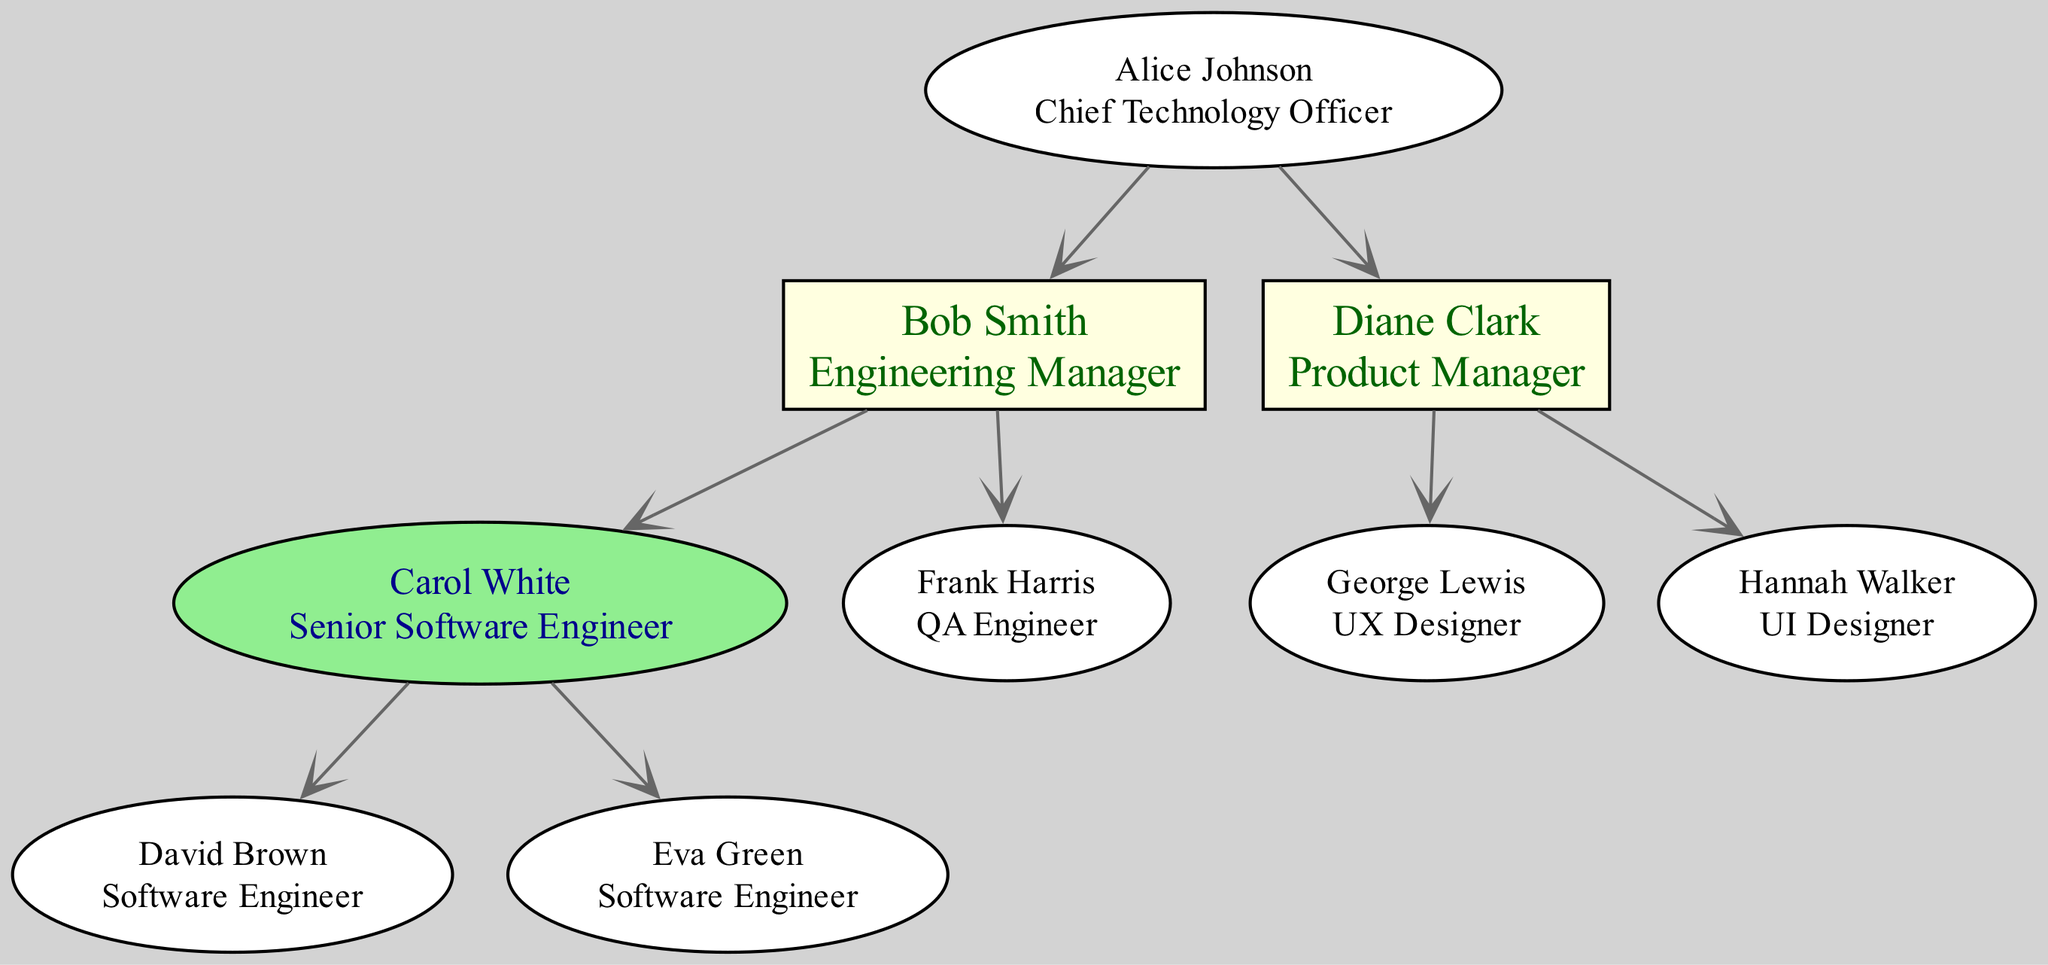What is the role of the person at the top of the hierarchy? The top of the hierarchy is occupied by the CTO, who is Alice Johnson. The role title directly corresponds to the highest level in the diagram.
Answer: Chief Technology Officer How many direct reports does the Engineering Manager have? The Engineering Manager, Bob Smith, has two direct reports: Carol White (Senior Software Engineer) and Frank Harris (QA Engineer). Thus, counting them gives two.
Answer: 2 Who reports to the Product Manager? The Product Manager, Diane Clark, has two direct reports: George Lewis (UX Designer) and Hannah Walker (UI Designer), so these two individuals report directly to her.
Answer: George Lewis, Hannah Walker Which role is represented by the node that has the most direct reports? The node with the most direct reports is the Engineering Manager, Bob Smith, who oversees Carol White and Frank Harris. This indicates that this role has the highest count of direct reports in the hierarchy.
Answer: Engineering Manager How many total nodes are in the hierarchy? The total nodes consist of the CTO and all direct and indirect reports. Counting these reveals that there are eight distinct nodes in this hierarchy.
Answer: 8 Which employee has the role of Senior Software Engineer? The employee with the role of Senior Software Engineer is Carol White, who reports directly to the Engineering Manager, Bob Smith.
Answer: Carol White What is the relationship between the CTO and the Product Manager? The Product Manager, Diane Clark, is a direct report of the CTO, Alice Johnson. This indicates a direct reporting relationship going from Diane Clark to Alice Johnson.
Answer: Reports To What is the role of the person named Eva Green? Eva Green holds the role of Software Engineer. She is listed under the Senior Software Engineer who is Carol White, indicating her position in the hierarchy.
Answer: Software Engineer How many QA Engineers are in the hierarchy? In the hierarchy, there is one QA Engineer, who is Frank Harris. This role is distinct and separate from the other engineering roles shown.
Answer: 1 